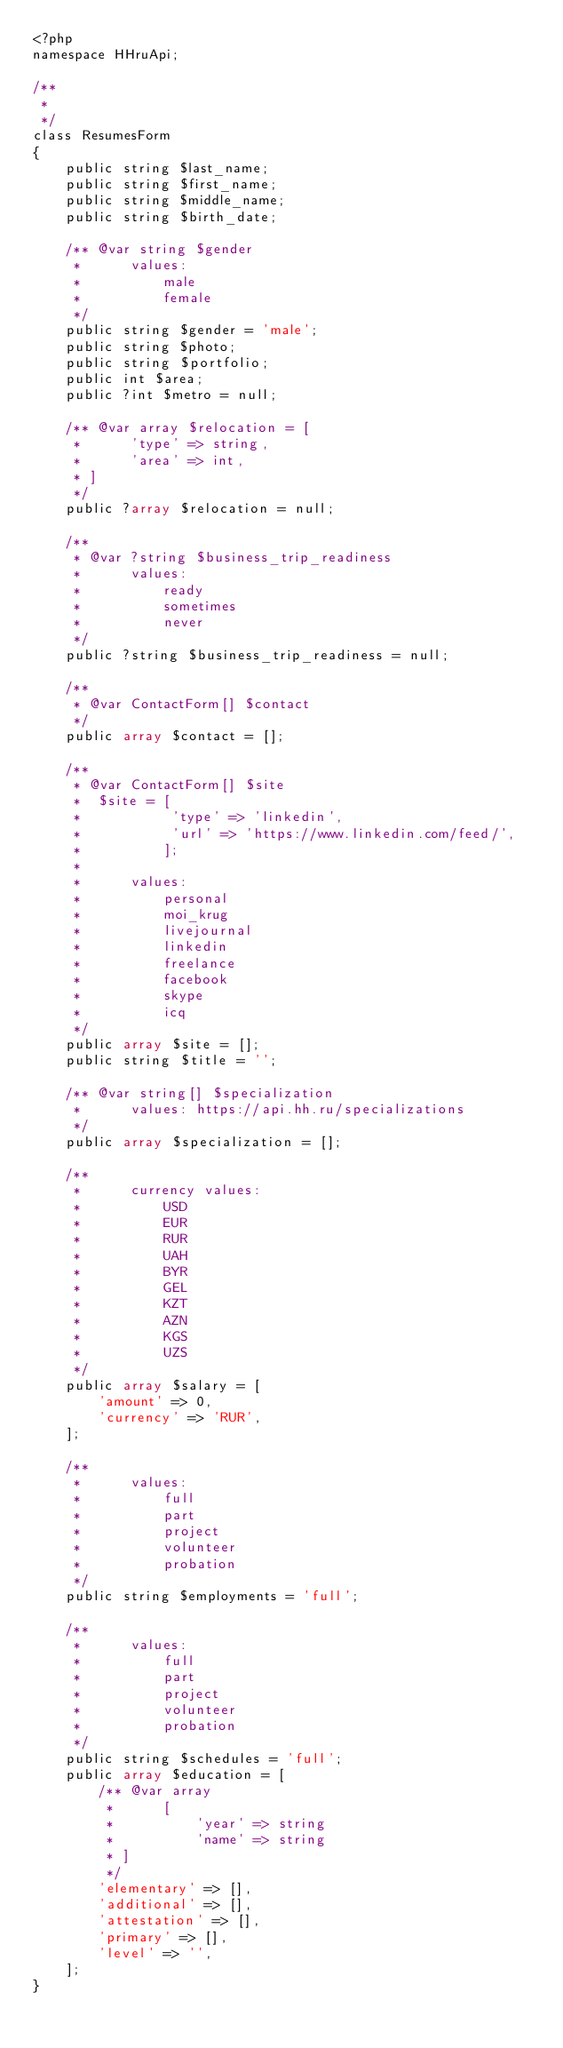Convert code to text. <code><loc_0><loc_0><loc_500><loc_500><_PHP_><?php
namespace HHruApi;

/**
 *
 */
class ResumesForm
{
    public string $last_name;
    public string $first_name;
    public string $middle_name;
    public string $birth_date;

    /** @var string $gender
     *      values:
     *          male
     *          female
     */
    public string $gender = 'male';
    public string $photo;
    public string $portfolio;
    public int $area;
    public ?int $metro = null;

    /** @var array $relocation = [
     *      'type' => string,
     *      'area' => int,
     * ]
     */
    public ?array $relocation = null;

    /**
     * @var ?string $business_trip_readiness
     *      values:
     *          ready
     *          sometimes
     *          never
     */
    public ?string $business_trip_readiness = null;

    /**
     * @var ContactForm[] $contact
     */
    public array $contact = [];

    /**
     * @var ContactForm[] $site
     *  $site = [
     *           'type' => 'linkedin',
     *           'url' => 'https://www.linkedin.com/feed/',
     *          ];
     *
     *      values:
     *          personal
     *          moi_krug
     *          livejournal
     *          linkedin
     *          freelance
     *          facebook
     *          skype
     *          icq
     */
    public array $site = [];
    public string $title = '';

    /** @var string[] $specialization
     *      values: https://api.hh.ru/specializations
     */
    public array $specialization = [];

    /**
     *      currency values:
     *          USD
     *          EUR
     *          RUR
     *          UAH
     *          BYR
     *          GEL
     *          KZT
     *          AZN
     *          KGS
     *          UZS
     */
    public array $salary = [
        'amount' => 0,
        'currency' => 'RUR',
    ];

    /**
     *      values:
     *          full
     *          part
     *          project
     *          volunteer
     *          probation
     */
    public string $employments = 'full';

    /**
     *      values:
     *          full
     *          part
     *          project
     *          volunteer
     *          probation
     */
    public string $schedules = 'full';
    public array $education = [
        /** @var array
         *      [
         *          'year' => string
         *          'name' => string
         * ]
         */
        'elementary' => [],
        'additional' => [],
        'attestation' => [],
        'primary' => [],
        'level' => '',
    ];
}</code> 